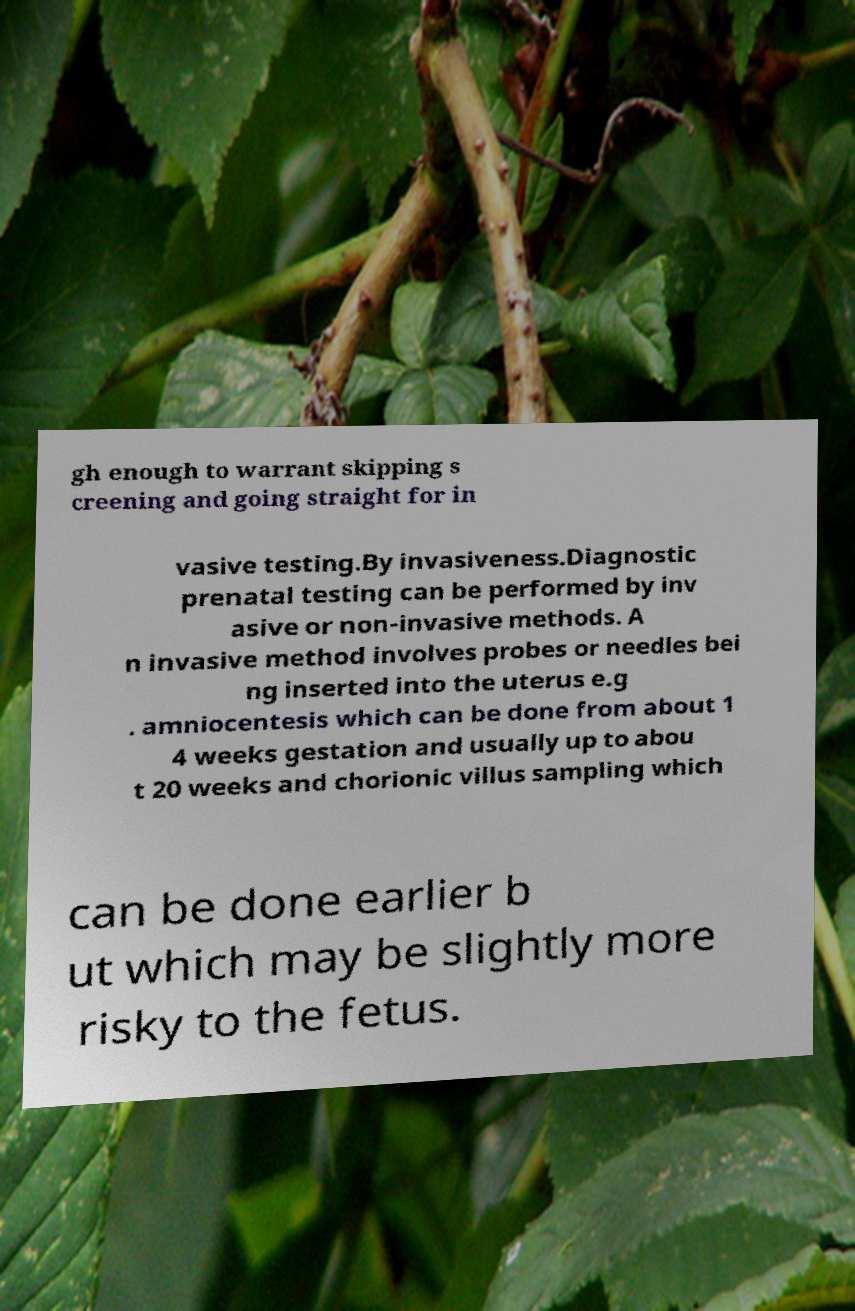Can you read and provide the text displayed in the image?This photo seems to have some interesting text. Can you extract and type it out for me? gh enough to warrant skipping s creening and going straight for in vasive testing.By invasiveness.Diagnostic prenatal testing can be performed by inv asive or non-invasive methods. A n invasive method involves probes or needles bei ng inserted into the uterus e.g . amniocentesis which can be done from about 1 4 weeks gestation and usually up to abou t 20 weeks and chorionic villus sampling which can be done earlier b ut which may be slightly more risky to the fetus. 